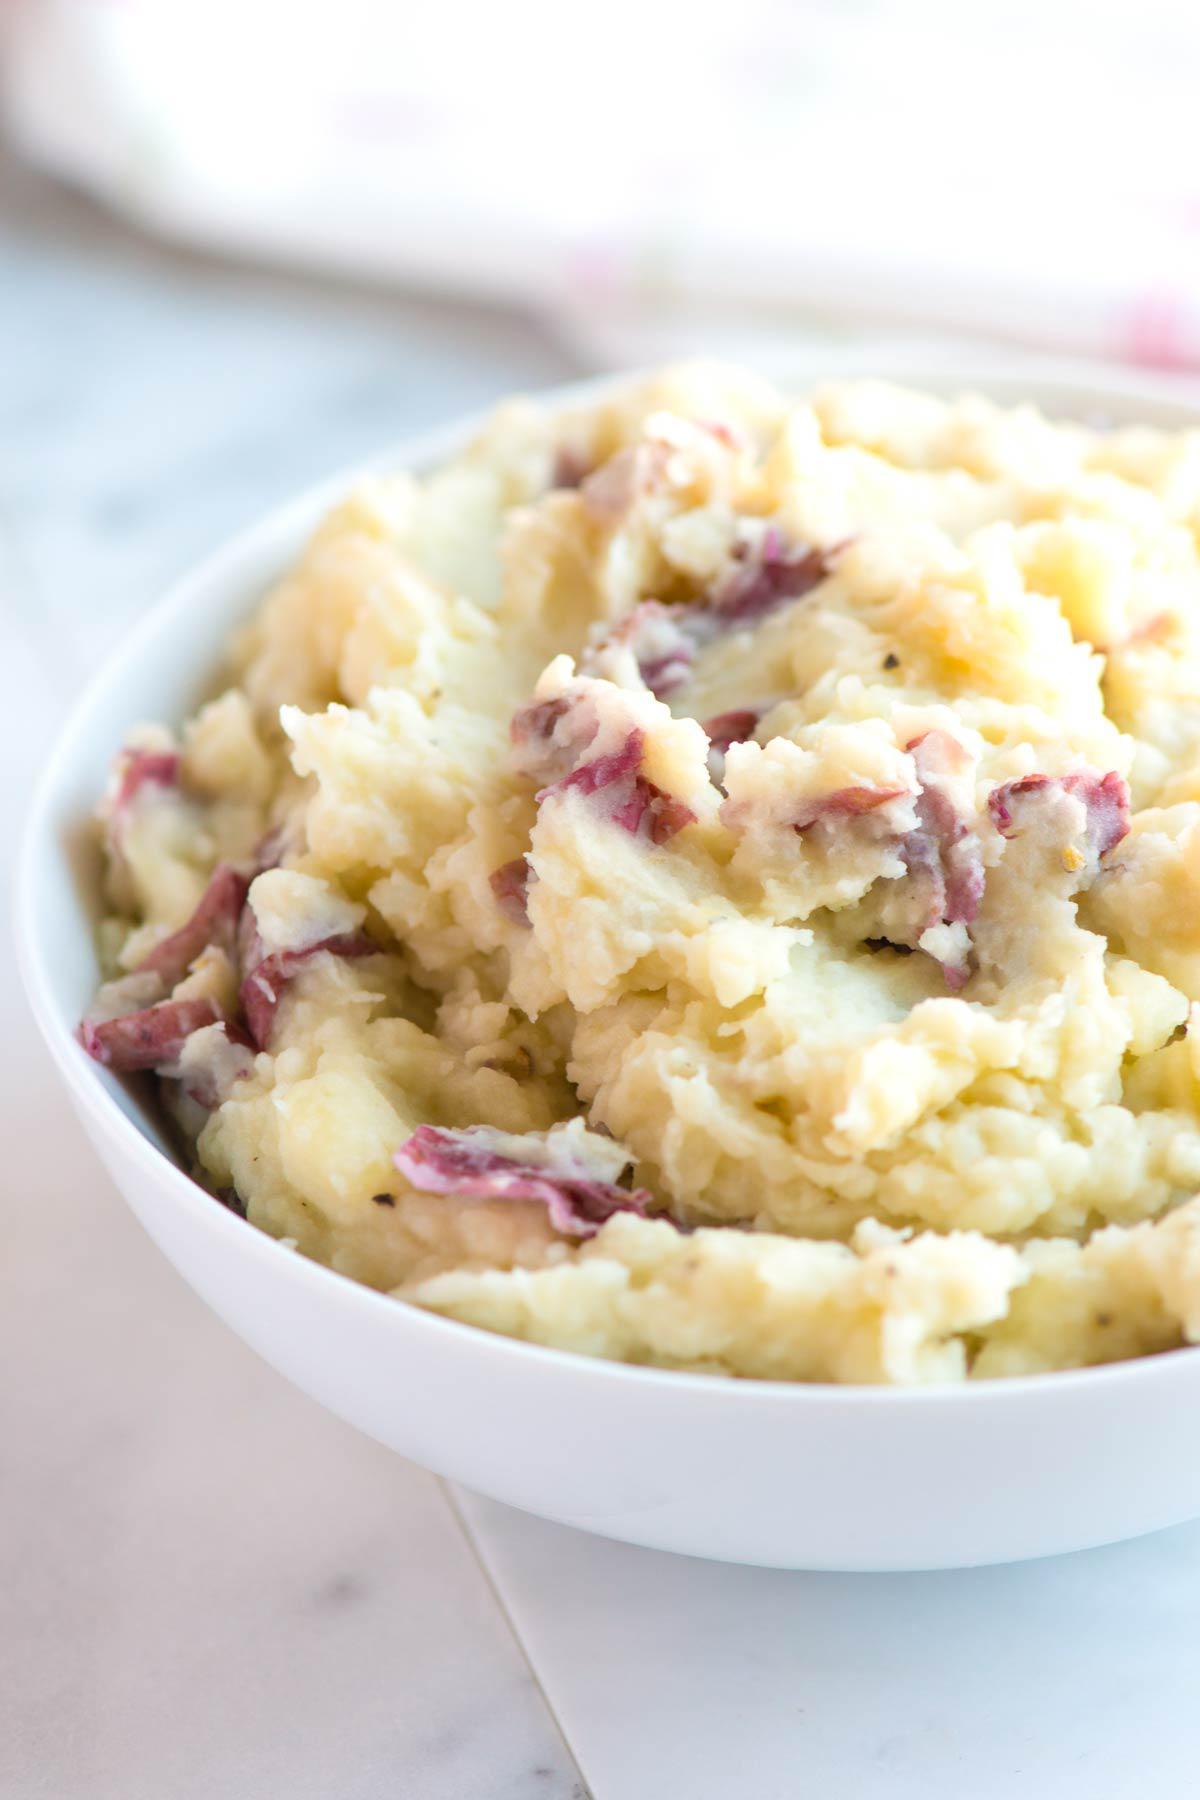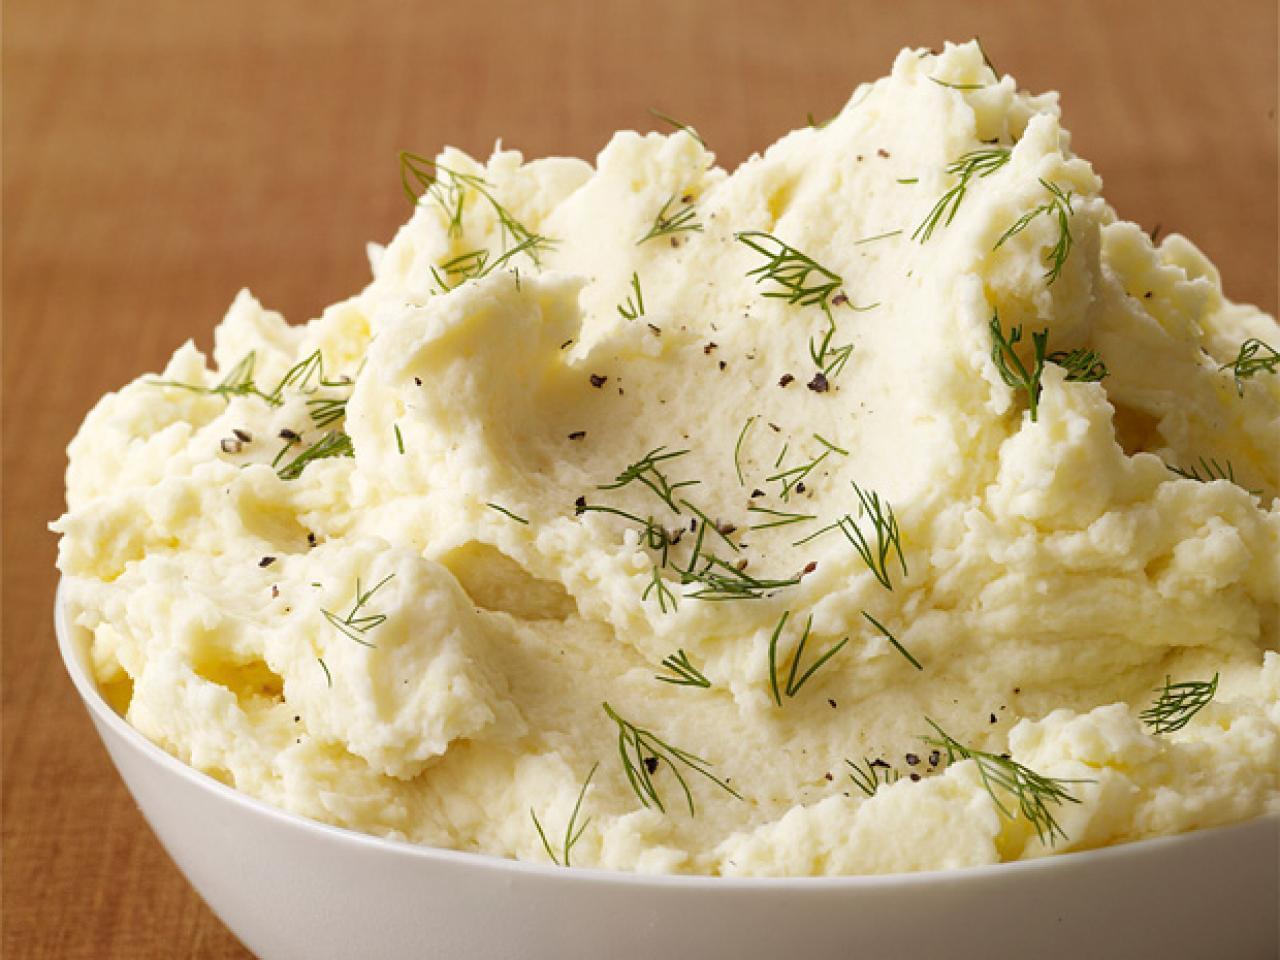The first image is the image on the left, the second image is the image on the right. Analyze the images presented: Is the assertion "At least one image shows mashed potatoes served in a white bowl." valid? Answer yes or no. Yes. The first image is the image on the left, the second image is the image on the right. For the images shown, is this caption "At least one bowl is white." true? Answer yes or no. Yes. 